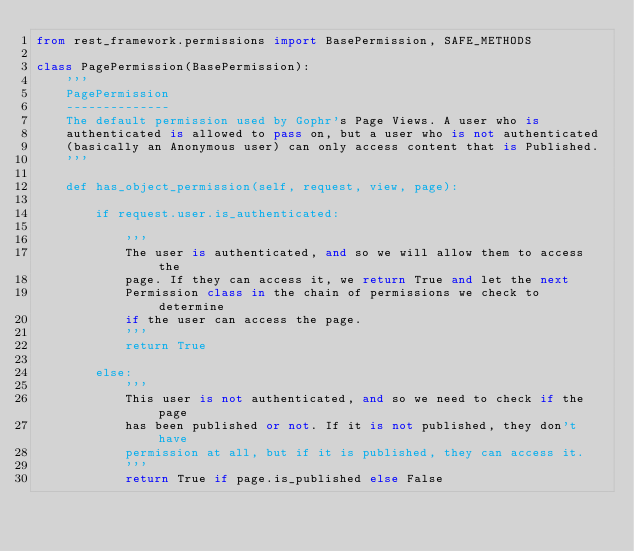<code> <loc_0><loc_0><loc_500><loc_500><_Python_>from rest_framework.permissions import BasePermission, SAFE_METHODS

class PagePermission(BasePermission):
    '''
    PagePermission
    --------------
    The default permission used by Gophr's Page Views. A user who is 
    authenticated is allowed to pass on, but a user who is not authenticated
    (basically an Anonymous user) can only access content that is Published.
    '''

    def has_object_permission(self, request, view, page):

        if request.user.is_authenticated:

            '''
            The user is authenticated, and so we will allow them to access the 
            page. If they can access it, we return True and let the next 
            Permission class in the chain of permissions we check to determine
            if the user can access the page.
            '''
            return True

        else:
            '''
            This user is not authenticated, and so we need to check if the page
            has been published or not. If it is not published, they don't have 
            permission at all, but if it is published, they can access it.
            '''
            return True if page.is_published else False</code> 